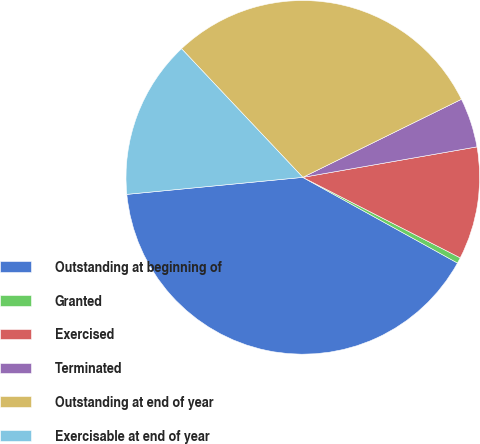Convert chart. <chart><loc_0><loc_0><loc_500><loc_500><pie_chart><fcel>Outstanding at beginning of<fcel>Granted<fcel>Exercised<fcel>Terminated<fcel>Outstanding at end of year<fcel>Exercisable at end of year<nl><fcel>40.41%<fcel>0.53%<fcel>10.28%<fcel>4.52%<fcel>29.75%<fcel>14.5%<nl></chart> 